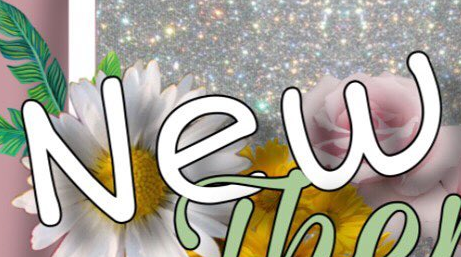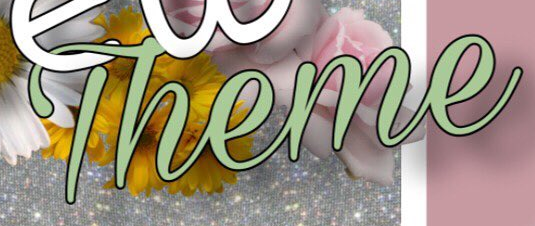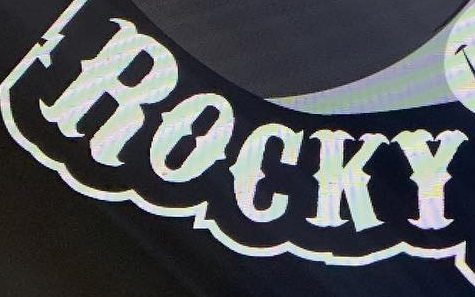What text appears in these images from left to right, separated by a semicolon? New; Theme; ROCKY 